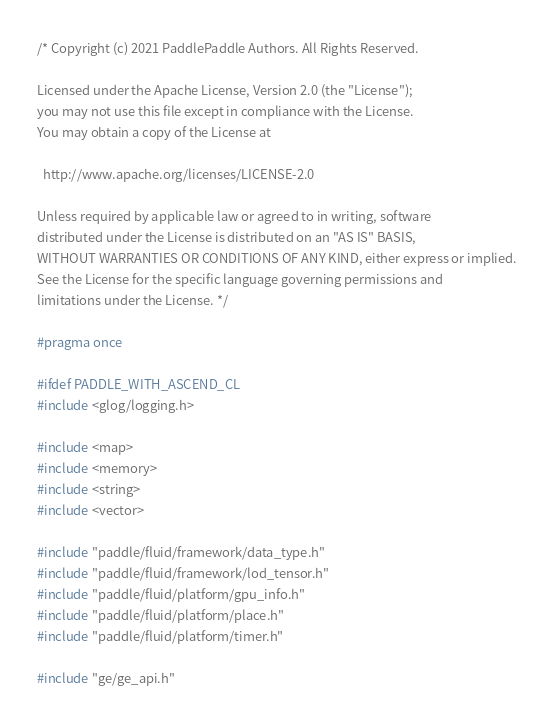<code> <loc_0><loc_0><loc_500><loc_500><_C_>/* Copyright (c) 2021 PaddlePaddle Authors. All Rights Reserved.

Licensed under the Apache License, Version 2.0 (the "License");
you may not use this file except in compliance with the License.
You may obtain a copy of the License at

  http://www.apache.org/licenses/LICENSE-2.0

Unless required by applicable law or agreed to in writing, software
distributed under the License is distributed on an "AS IS" BASIS,
WITHOUT WARRANTIES OR CONDITIONS OF ANY KIND, either express or implied.
See the License for the specific language governing permissions and
limitations under the License. */

#pragma once

#ifdef PADDLE_WITH_ASCEND_CL
#include <glog/logging.h>

#include <map>
#include <memory>
#include <string>
#include <vector>

#include "paddle/fluid/framework/data_type.h"
#include "paddle/fluid/framework/lod_tensor.h"
#include "paddle/fluid/platform/gpu_info.h"
#include "paddle/fluid/platform/place.h"
#include "paddle/fluid/platform/timer.h"

#include "ge/ge_api.h"</code> 